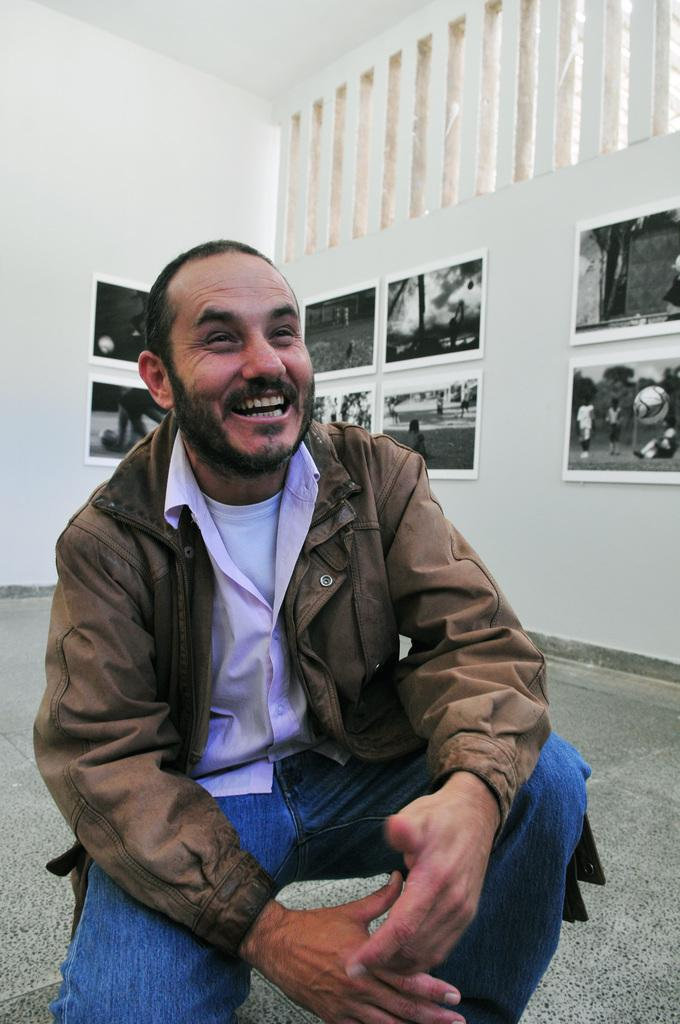What is the person in the image doing? The person is sitting in the squat position in the image. What is the person's facial expression in the image? The person is smiling. What can be seen behind the person in the image? There is a wall visible in the image. What is attached to the wall in the image? Photo frames are attached to the wall. What type of knowledge can be gained from the potato in the image? There is no potato present in the image, so no knowledge can be gained from it. What is the person's occupation in the image, and how does it relate to the carpenter? The person's occupation is not mentioned in the image, and there is no reference to a carpenter. 